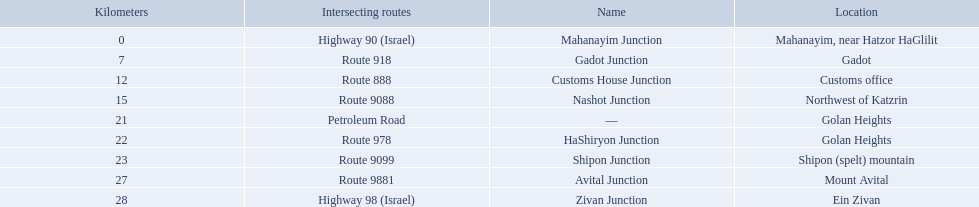What are all the are all the locations on the highway 91 (israel)? Mahanayim, near Hatzor HaGlilit, Gadot, Customs office, Northwest of Katzrin, Golan Heights, Golan Heights, Shipon (spelt) mountain, Mount Avital, Ein Zivan. What are the distance values in kilometers for ein zivan, gadot junction and shipon junction? 7, 23, 28. Which is the least distance away? 7. What is the name? Gadot Junction. How many kilometers away is shipon junction? 23. How many kilometers away is avital junction? 27. Which one is closer to nashot junction? Shipon Junction. 